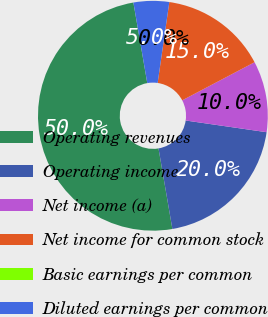Convert chart to OTSL. <chart><loc_0><loc_0><loc_500><loc_500><pie_chart><fcel>Operating revenues<fcel>Operating income<fcel>Net income (a)<fcel>Net income for common stock<fcel>Basic earnings per common<fcel>Diluted earnings per common<nl><fcel>49.99%<fcel>20.0%<fcel>10.0%<fcel>15.0%<fcel>0.0%<fcel>5.0%<nl></chart> 